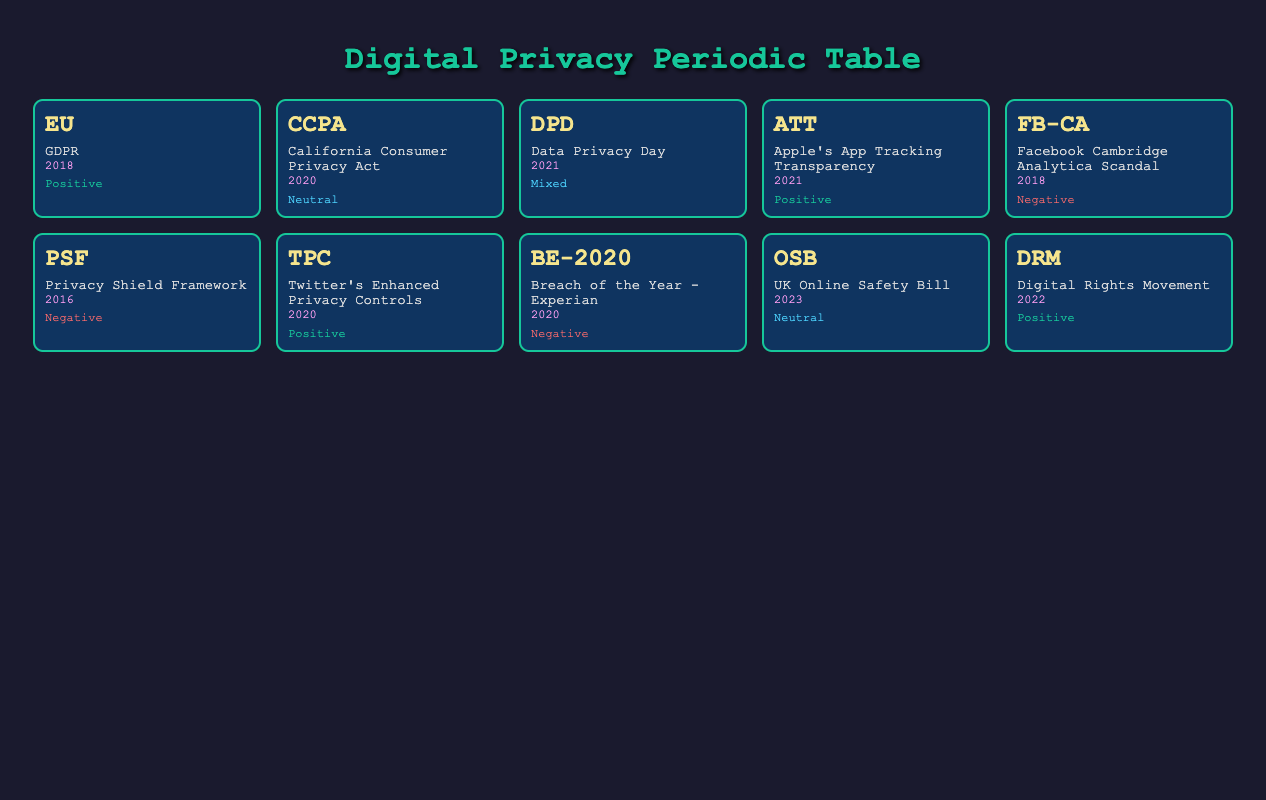What is the public sentiment regarding the GDPR in 2018? The table indicates that the public sentiment towards GDPR in 2018 is "Positive."
Answer: Positive Which legislation introduced in 2020 has a negative public sentiment? By reviewing the entries for 2020, the "Breach of the Year - Experian" shows a negative sentiment.
Answer: Breach of the Year - Experian How many entries have a "Neutral" public sentiment? There are two entries with a "Neutral" sentiment: "California Consumer Privacy Act" and "UK Online Safety Bill."
Answer: 2 What was the major impact of the Facebook Cambridge Analytica scandal? According to the table, the major impact highlighted was that it brought significant scrutiny on data practices of social media companies.
Answer: Brought significant scrutiny on data practices of social media companies In which year was the Digital Rights Movement initiated? The entry for the Digital Rights Movement indicates it was initiated in 2022.
Answer: 2022 Are there any entries with a "Mixed" public sentiment? Yes, the table shows one entry, which is "Data Privacy Day" having a mixed sentiment.
Answer: Yes What is the average public sentiment for entries from the year 2021? The entries "Data Privacy Day" (Mixed), "Apple's App Tracking Transparency" (Positive) yield a combined sentiment value, however, it can’t be averaged numerically without a defined scale. Still, the qualitative aspect suggests a generally positive outlook due to the positive sentiment.
Answer: Cannot be averaged numerically; qualitatively generally positive What major impact did Twitter's Enhanced Privacy Controls have? The table states that it strengthened user trust in digital communication platforms, reflecting positively on public sentiment.
Answer: Strengthened user trust in digital communication platforms How does the public sentiment towards the Privacy Shield Framework compare to the GDPR? The GDPR has a positive sentiment, while the Privacy Shield Framework has a negative sentiment, highlighting contrasting public perceptions of each.
Answer: Contrasting, GDPR is positive, Privacy Shield is negative 